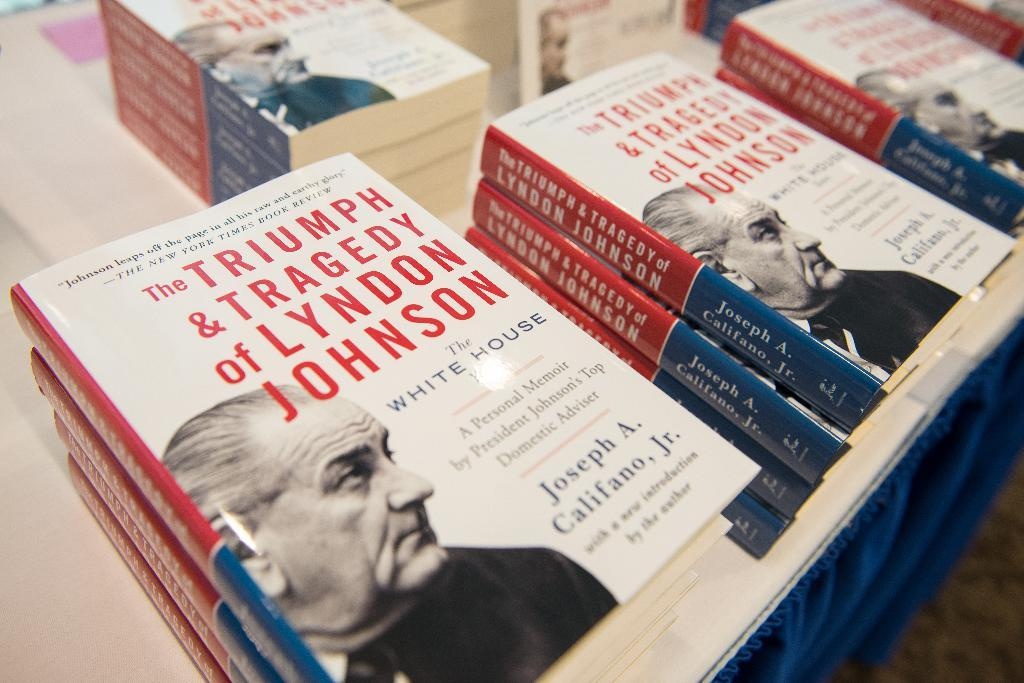Provide a one-sentence caption for the provided image. The triumph and tragedy of Lyndon Johnson by Joseph A. Califano, Jr. 